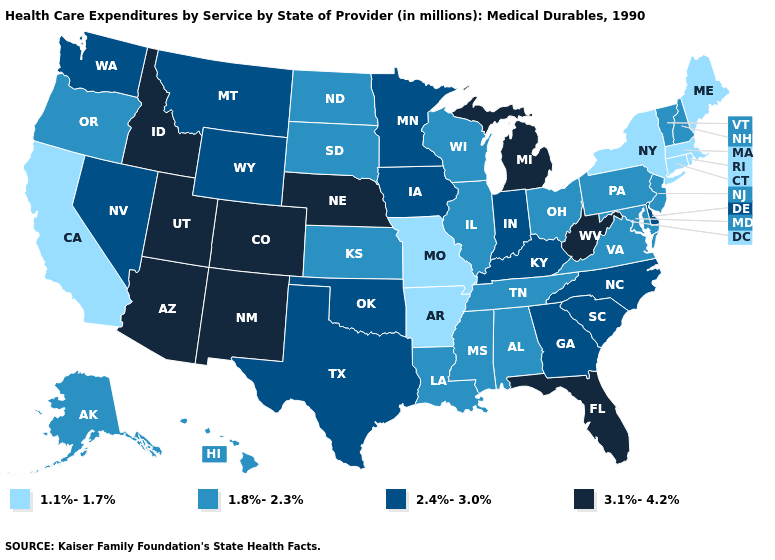Which states have the lowest value in the USA?
Quick response, please. Arkansas, California, Connecticut, Maine, Massachusetts, Missouri, New York, Rhode Island. Which states have the lowest value in the South?
Give a very brief answer. Arkansas. Name the states that have a value in the range 2.4%-3.0%?
Answer briefly. Delaware, Georgia, Indiana, Iowa, Kentucky, Minnesota, Montana, Nevada, North Carolina, Oklahoma, South Carolina, Texas, Washington, Wyoming. Name the states that have a value in the range 2.4%-3.0%?
Be succinct. Delaware, Georgia, Indiana, Iowa, Kentucky, Minnesota, Montana, Nevada, North Carolina, Oklahoma, South Carolina, Texas, Washington, Wyoming. Which states hav the highest value in the MidWest?
Quick response, please. Michigan, Nebraska. Name the states that have a value in the range 1.1%-1.7%?
Be succinct. Arkansas, California, Connecticut, Maine, Massachusetts, Missouri, New York, Rhode Island. What is the value of Louisiana?
Concise answer only. 1.8%-2.3%. What is the value of Texas?
Keep it brief. 2.4%-3.0%. Which states have the highest value in the USA?
Answer briefly. Arizona, Colorado, Florida, Idaho, Michigan, Nebraska, New Mexico, Utah, West Virginia. Which states have the lowest value in the USA?
Concise answer only. Arkansas, California, Connecticut, Maine, Massachusetts, Missouri, New York, Rhode Island. What is the value of New Mexico?
Short answer required. 3.1%-4.2%. What is the lowest value in states that border North Dakota?
Be succinct. 1.8%-2.3%. Which states have the lowest value in the USA?
Short answer required. Arkansas, California, Connecticut, Maine, Massachusetts, Missouri, New York, Rhode Island. Does North Carolina have the highest value in the USA?
Be succinct. No. Name the states that have a value in the range 1.1%-1.7%?
Keep it brief. Arkansas, California, Connecticut, Maine, Massachusetts, Missouri, New York, Rhode Island. 